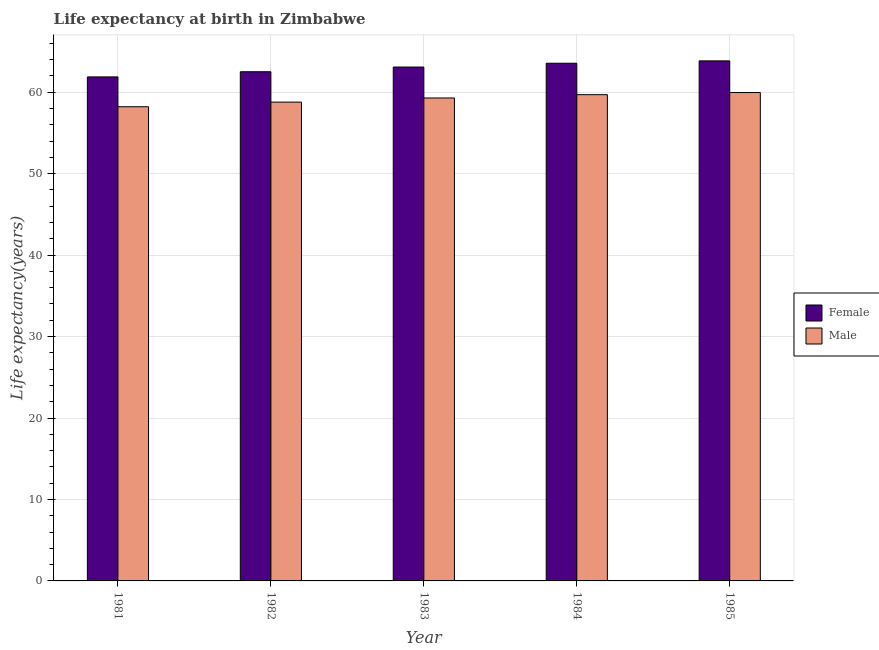Are the number of bars per tick equal to the number of legend labels?
Offer a very short reply. Yes. Are the number of bars on each tick of the X-axis equal?
Make the answer very short. Yes. How many bars are there on the 5th tick from the left?
Your answer should be very brief. 2. What is the life expectancy(female) in 1981?
Your answer should be very brief. 61.88. Across all years, what is the maximum life expectancy(male)?
Give a very brief answer. 59.96. Across all years, what is the minimum life expectancy(female)?
Ensure brevity in your answer.  61.88. In which year was the life expectancy(female) maximum?
Keep it short and to the point. 1985. What is the total life expectancy(male) in the graph?
Keep it short and to the point. 295.96. What is the difference between the life expectancy(female) in 1984 and that in 1985?
Provide a succinct answer. -0.29. What is the difference between the life expectancy(male) in 1985 and the life expectancy(female) in 1983?
Provide a short and direct response. 0.67. What is the average life expectancy(female) per year?
Provide a short and direct response. 62.98. What is the ratio of the life expectancy(female) in 1982 to that in 1985?
Give a very brief answer. 0.98. What is the difference between the highest and the second highest life expectancy(male)?
Offer a terse response. 0.26. What is the difference between the highest and the lowest life expectancy(male)?
Offer a terse response. 1.74. What does the 2nd bar from the left in 1983 represents?
Offer a very short reply. Male. How many bars are there?
Your answer should be compact. 10. How many years are there in the graph?
Your answer should be compact. 5. What is the difference between two consecutive major ticks on the Y-axis?
Provide a short and direct response. 10. Are the values on the major ticks of Y-axis written in scientific E-notation?
Offer a very short reply. No. Does the graph contain any zero values?
Your answer should be very brief. No. Does the graph contain grids?
Keep it short and to the point. Yes. How many legend labels are there?
Your answer should be compact. 2. How are the legend labels stacked?
Your response must be concise. Vertical. What is the title of the graph?
Your answer should be compact. Life expectancy at birth in Zimbabwe. Does "Investment" appear as one of the legend labels in the graph?
Provide a short and direct response. No. What is the label or title of the Y-axis?
Offer a terse response. Life expectancy(years). What is the Life expectancy(years) in Female in 1981?
Ensure brevity in your answer.  61.88. What is the Life expectancy(years) in Male in 1981?
Your answer should be compact. 58.22. What is the Life expectancy(years) of Female in 1982?
Make the answer very short. 62.52. What is the Life expectancy(years) in Male in 1982?
Your answer should be very brief. 58.79. What is the Life expectancy(years) in Female in 1983?
Ensure brevity in your answer.  63.09. What is the Life expectancy(years) in Male in 1983?
Give a very brief answer. 59.3. What is the Life expectancy(years) of Female in 1984?
Offer a very short reply. 63.56. What is the Life expectancy(years) of Male in 1984?
Your response must be concise. 59.7. What is the Life expectancy(years) in Female in 1985?
Make the answer very short. 63.85. What is the Life expectancy(years) of Male in 1985?
Your answer should be very brief. 59.96. Across all years, what is the maximum Life expectancy(years) of Female?
Your response must be concise. 63.85. Across all years, what is the maximum Life expectancy(years) in Male?
Give a very brief answer. 59.96. Across all years, what is the minimum Life expectancy(years) in Female?
Make the answer very short. 61.88. Across all years, what is the minimum Life expectancy(years) of Male?
Keep it short and to the point. 58.22. What is the total Life expectancy(years) of Female in the graph?
Your answer should be very brief. 314.9. What is the total Life expectancy(years) of Male in the graph?
Make the answer very short. 295.96. What is the difference between the Life expectancy(years) in Female in 1981 and that in 1982?
Your response must be concise. -0.64. What is the difference between the Life expectancy(years) in Male in 1981 and that in 1982?
Provide a succinct answer. -0.57. What is the difference between the Life expectancy(years) of Female in 1981 and that in 1983?
Make the answer very short. -1.21. What is the difference between the Life expectancy(years) of Male in 1981 and that in 1983?
Keep it short and to the point. -1.08. What is the difference between the Life expectancy(years) in Female in 1981 and that in 1984?
Provide a short and direct response. -1.68. What is the difference between the Life expectancy(years) in Male in 1981 and that in 1984?
Keep it short and to the point. -1.48. What is the difference between the Life expectancy(years) of Female in 1981 and that in 1985?
Your answer should be compact. -1.97. What is the difference between the Life expectancy(years) of Male in 1981 and that in 1985?
Ensure brevity in your answer.  -1.75. What is the difference between the Life expectancy(years) of Female in 1982 and that in 1983?
Provide a succinct answer. -0.58. What is the difference between the Life expectancy(years) in Male in 1982 and that in 1983?
Provide a succinct answer. -0.51. What is the difference between the Life expectancy(years) in Female in 1982 and that in 1984?
Give a very brief answer. -1.04. What is the difference between the Life expectancy(years) in Male in 1982 and that in 1984?
Give a very brief answer. -0.92. What is the difference between the Life expectancy(years) in Female in 1982 and that in 1985?
Your response must be concise. -1.33. What is the difference between the Life expectancy(years) of Male in 1982 and that in 1985?
Offer a terse response. -1.18. What is the difference between the Life expectancy(years) in Female in 1983 and that in 1984?
Your answer should be very brief. -0.47. What is the difference between the Life expectancy(years) in Male in 1983 and that in 1984?
Make the answer very short. -0.41. What is the difference between the Life expectancy(years) of Female in 1983 and that in 1985?
Offer a very short reply. -0.76. What is the difference between the Life expectancy(years) in Male in 1983 and that in 1985?
Your response must be concise. -0.67. What is the difference between the Life expectancy(years) of Female in 1984 and that in 1985?
Offer a very short reply. -0.29. What is the difference between the Life expectancy(years) in Male in 1984 and that in 1985?
Ensure brevity in your answer.  -0.26. What is the difference between the Life expectancy(years) in Female in 1981 and the Life expectancy(years) in Male in 1982?
Give a very brief answer. 3.1. What is the difference between the Life expectancy(years) of Female in 1981 and the Life expectancy(years) of Male in 1983?
Provide a short and direct response. 2.59. What is the difference between the Life expectancy(years) of Female in 1981 and the Life expectancy(years) of Male in 1984?
Provide a short and direct response. 2.18. What is the difference between the Life expectancy(years) of Female in 1981 and the Life expectancy(years) of Male in 1985?
Provide a succinct answer. 1.92. What is the difference between the Life expectancy(years) in Female in 1982 and the Life expectancy(years) in Male in 1983?
Offer a very short reply. 3.22. What is the difference between the Life expectancy(years) in Female in 1982 and the Life expectancy(years) in Male in 1984?
Make the answer very short. 2.81. What is the difference between the Life expectancy(years) in Female in 1982 and the Life expectancy(years) in Male in 1985?
Give a very brief answer. 2.55. What is the difference between the Life expectancy(years) in Female in 1983 and the Life expectancy(years) in Male in 1984?
Give a very brief answer. 3.39. What is the difference between the Life expectancy(years) in Female in 1983 and the Life expectancy(years) in Male in 1985?
Your answer should be compact. 3.13. What is the difference between the Life expectancy(years) of Female in 1984 and the Life expectancy(years) of Male in 1985?
Keep it short and to the point. 3.6. What is the average Life expectancy(years) of Female per year?
Provide a succinct answer. 62.98. What is the average Life expectancy(years) in Male per year?
Provide a succinct answer. 59.19. In the year 1981, what is the difference between the Life expectancy(years) of Female and Life expectancy(years) of Male?
Provide a short and direct response. 3.66. In the year 1982, what is the difference between the Life expectancy(years) of Female and Life expectancy(years) of Male?
Give a very brief answer. 3.73. In the year 1983, what is the difference between the Life expectancy(years) in Female and Life expectancy(years) in Male?
Provide a short and direct response. 3.8. In the year 1984, what is the difference between the Life expectancy(years) in Female and Life expectancy(years) in Male?
Provide a succinct answer. 3.86. In the year 1985, what is the difference between the Life expectancy(years) in Female and Life expectancy(years) in Male?
Keep it short and to the point. 3.89. What is the ratio of the Life expectancy(years) of Female in 1981 to that in 1982?
Give a very brief answer. 0.99. What is the ratio of the Life expectancy(years) of Male in 1981 to that in 1982?
Your answer should be compact. 0.99. What is the ratio of the Life expectancy(years) in Female in 1981 to that in 1983?
Give a very brief answer. 0.98. What is the ratio of the Life expectancy(years) in Male in 1981 to that in 1983?
Your answer should be very brief. 0.98. What is the ratio of the Life expectancy(years) in Female in 1981 to that in 1984?
Your answer should be compact. 0.97. What is the ratio of the Life expectancy(years) in Male in 1981 to that in 1984?
Offer a terse response. 0.98. What is the ratio of the Life expectancy(years) in Female in 1981 to that in 1985?
Give a very brief answer. 0.97. What is the ratio of the Life expectancy(years) in Male in 1981 to that in 1985?
Provide a succinct answer. 0.97. What is the ratio of the Life expectancy(years) of Male in 1982 to that in 1983?
Provide a succinct answer. 0.99. What is the ratio of the Life expectancy(years) in Female in 1982 to that in 1984?
Your response must be concise. 0.98. What is the ratio of the Life expectancy(years) of Male in 1982 to that in 1984?
Ensure brevity in your answer.  0.98. What is the ratio of the Life expectancy(years) of Female in 1982 to that in 1985?
Your response must be concise. 0.98. What is the ratio of the Life expectancy(years) in Male in 1982 to that in 1985?
Your answer should be compact. 0.98. What is the ratio of the Life expectancy(years) of Female in 1983 to that in 1984?
Provide a succinct answer. 0.99. What is the ratio of the Life expectancy(years) in Male in 1983 to that in 1984?
Your answer should be compact. 0.99. What is the ratio of the Life expectancy(years) of Female in 1983 to that in 1985?
Provide a succinct answer. 0.99. What is the ratio of the Life expectancy(years) of Male in 1983 to that in 1985?
Your answer should be compact. 0.99. What is the ratio of the Life expectancy(years) in Female in 1984 to that in 1985?
Make the answer very short. 1. What is the difference between the highest and the second highest Life expectancy(years) of Female?
Offer a very short reply. 0.29. What is the difference between the highest and the second highest Life expectancy(years) in Male?
Provide a succinct answer. 0.26. What is the difference between the highest and the lowest Life expectancy(years) of Female?
Give a very brief answer. 1.97. What is the difference between the highest and the lowest Life expectancy(years) in Male?
Make the answer very short. 1.75. 